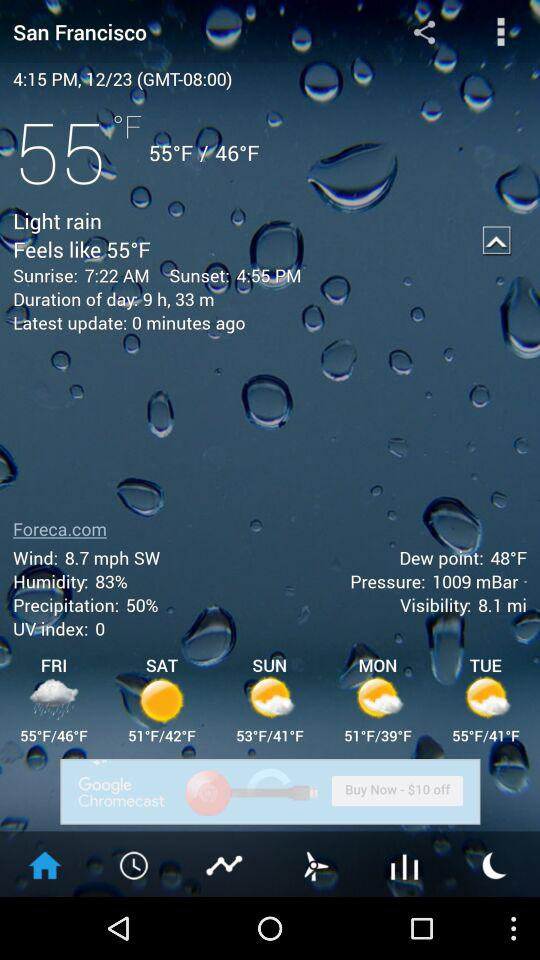How many minutes ago was it last updated? It was last updated 0 minutes ago. 